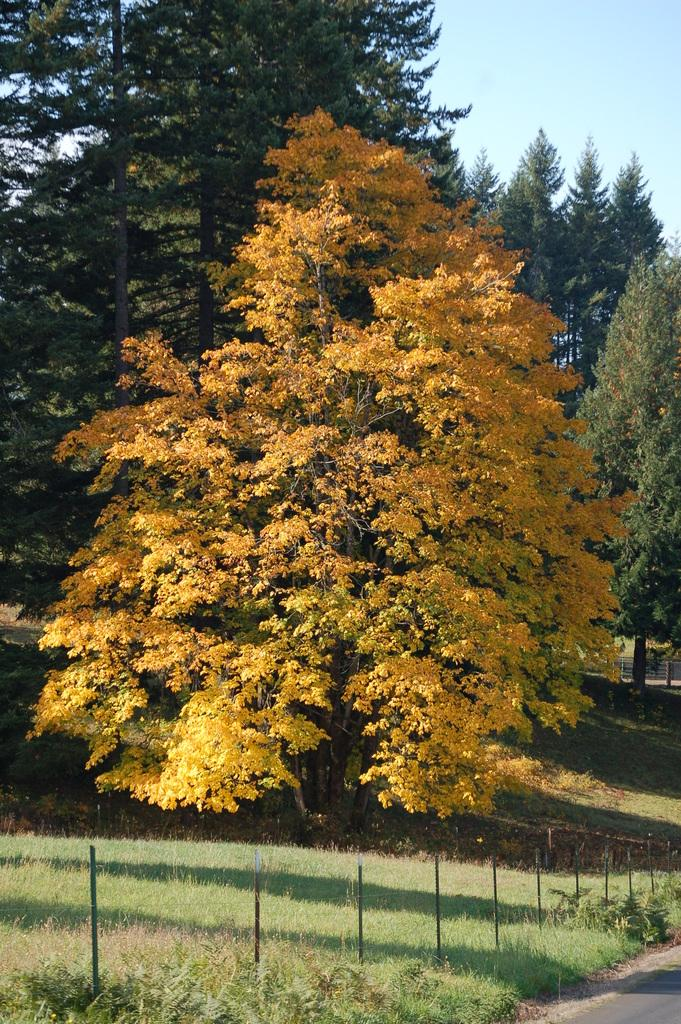What can be seen on the right side of the image? There is a road on the right side of the image. What is located on the left side of the image? There is a fence and trees on the left side of the image. What type of vegetation is present on the ground in the image? There is grass on the ground in the image. What is visible in the background of the image? There are trees and clouds in the sky in the background of the image. Can you see any fairies playing with a bead on a branch in the image? There are no fairies, beads, or branches present in the image. What type of creature is shown interacting with the bead on the branch in the image? There is no creature shown interacting with a bead on a branch in the image; only the road, fence, trees, grass, and clouds are present. 